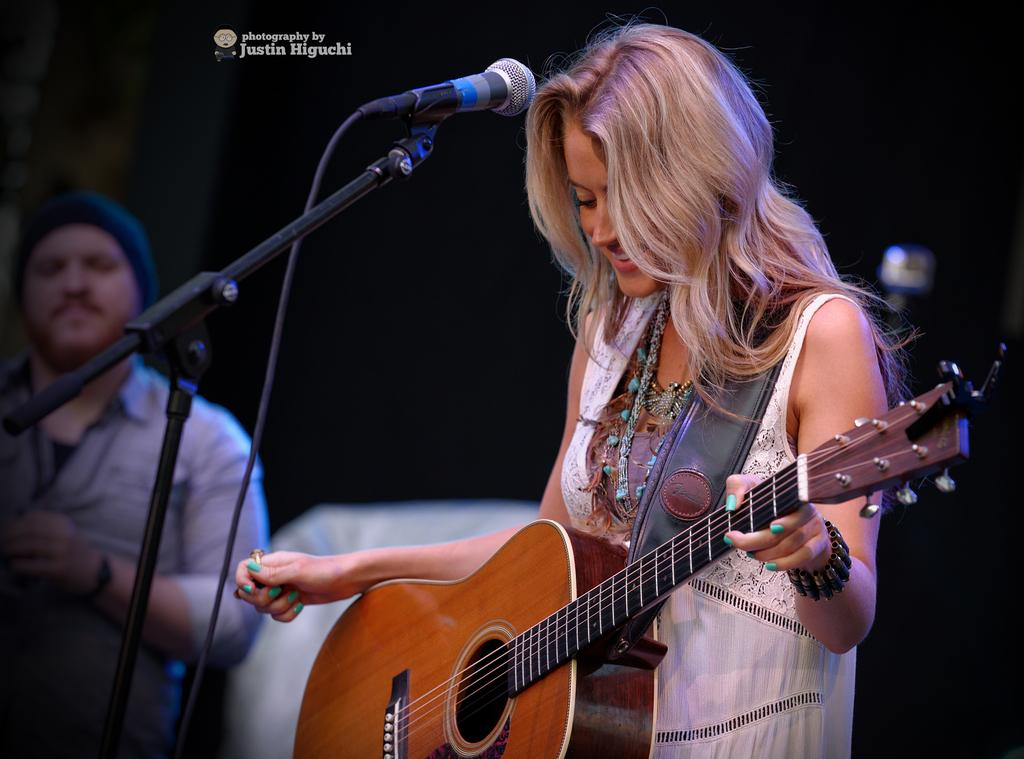What is the woman in the image doing? The woman is standing and playing the guitar in the image. What object is present near the woman? There is a microphone in the image, and it is on the left side. Can you describe the man in the image? The man is standing on the left side in the image. What is the man's relationship to the woman? The facts provided do not give information about the man's relationship to the woman. What type of jelly is the woman using to play the guitar in the image? There is no jelly present in the image, and the woman is playing the guitar with her hands, not with jelly. 